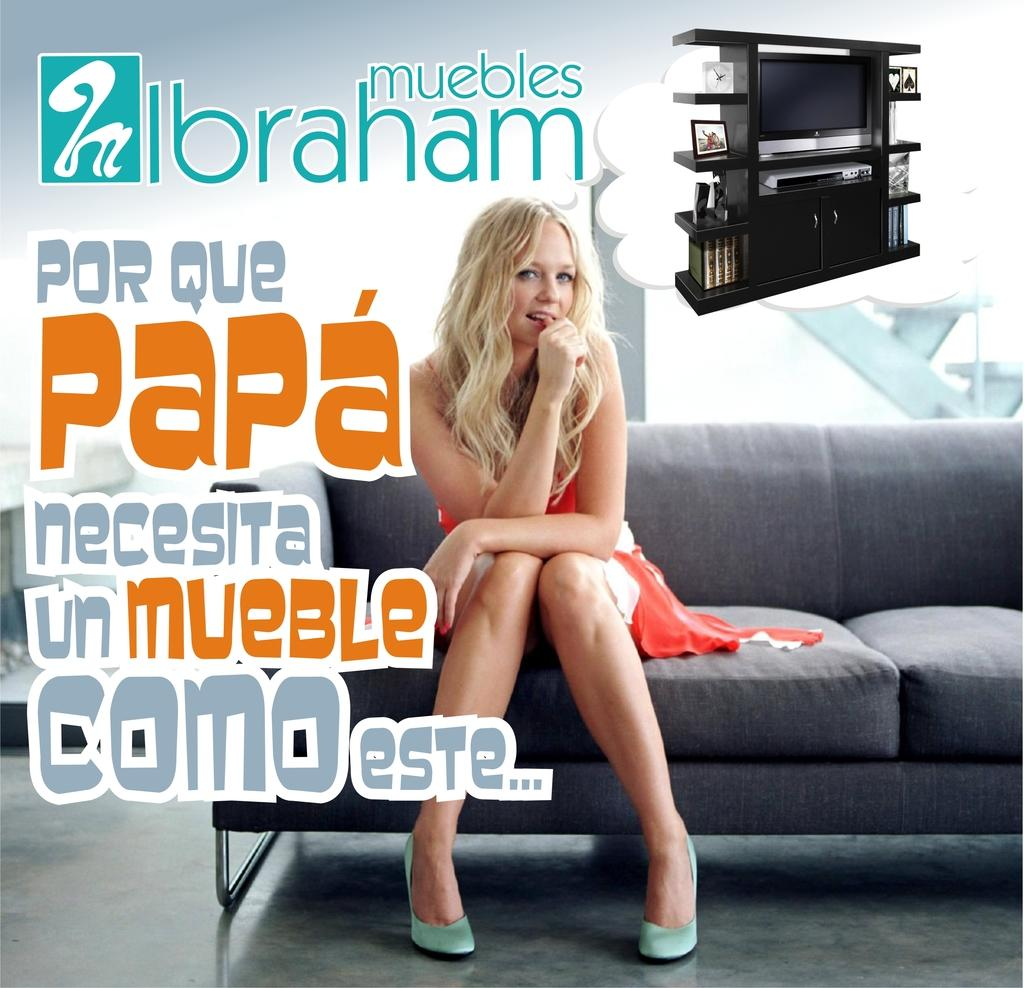<image>
Write a terse but informative summary of the picture. The ads with a young woman sitting on the sofa is made for Muebles Ibraham. 